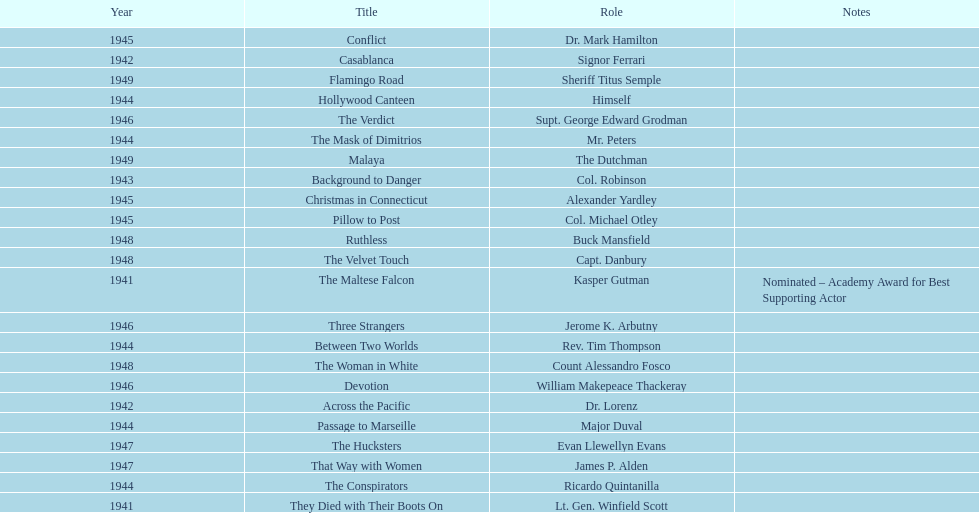Would you be able to parse every entry in this table? {'header': ['Year', 'Title', 'Role', 'Notes'], 'rows': [['1945', 'Conflict', 'Dr. Mark Hamilton', ''], ['1942', 'Casablanca', 'Signor Ferrari', ''], ['1949', 'Flamingo Road', 'Sheriff Titus Semple', ''], ['1944', 'Hollywood Canteen', 'Himself', ''], ['1946', 'The Verdict', 'Supt. George Edward Grodman', ''], ['1944', 'The Mask of Dimitrios', 'Mr. Peters', ''], ['1949', 'Malaya', 'The Dutchman', ''], ['1943', 'Background to Danger', 'Col. Robinson', ''], ['1945', 'Christmas in Connecticut', 'Alexander Yardley', ''], ['1945', 'Pillow to Post', 'Col. Michael Otley', ''], ['1948', 'Ruthless', 'Buck Mansfield', ''], ['1948', 'The Velvet Touch', 'Capt. Danbury', ''], ['1941', 'The Maltese Falcon', 'Kasper Gutman', 'Nominated – Academy Award for Best Supporting Actor'], ['1946', 'Three Strangers', 'Jerome K. Arbutny', ''], ['1944', 'Between Two Worlds', 'Rev. Tim Thompson', ''], ['1948', 'The Woman in White', 'Count Alessandro Fosco', ''], ['1946', 'Devotion', 'William Makepeace Thackeray', ''], ['1942', 'Across the Pacific', 'Dr. Lorenz', ''], ['1944', 'Passage to Marseille', 'Major Duval', ''], ['1947', 'The Hucksters', 'Evan Llewellyn Evans', ''], ['1947', 'That Way with Women', 'James P. Alden', ''], ['1944', 'The Conspirators', 'Ricardo Quintanilla', ''], ['1941', 'They Died with Their Boots On', 'Lt. Gen. Winfield Scott', '']]} What movies did greenstreet act for in 1946? Three Strangers, Devotion, The Verdict. 